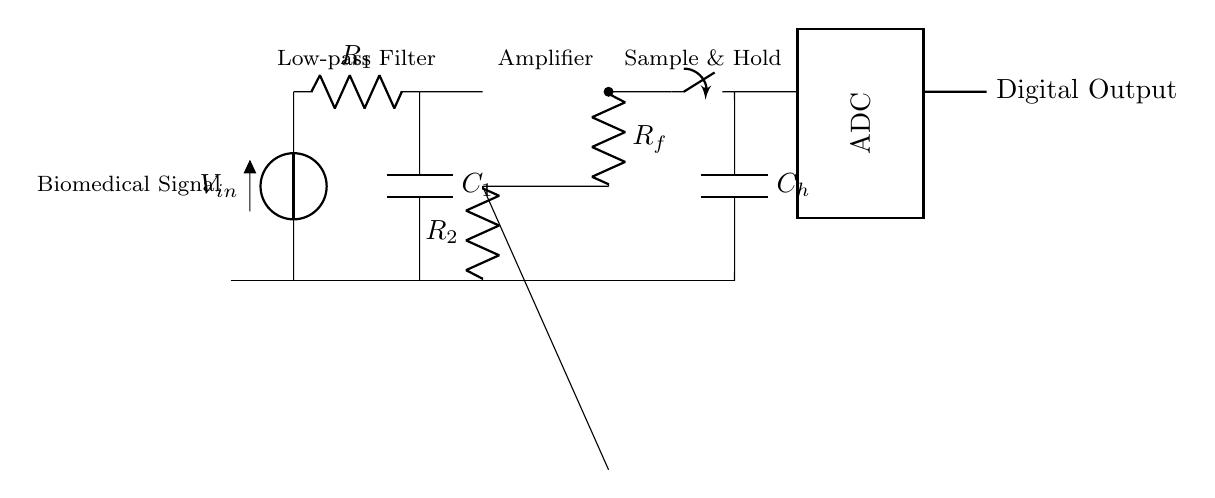What is the primary function of the component labeled as "V_in"? The component labeled as "V_in" represents the input voltage from a biomedical signal, which is the signal that the circuit is designed to process.
Answer: input voltage What type of filter is represented in the circuit? The low-pass filter is defined by the resistor R1 and capacitor C1, which filter out high-frequency noise from the input signal.
Answer: Low-pass filter What are the two components used in the amplifier section? The amplifier section uses a resistor (R2) and a feedback resistor (R_f), which are essential for controlling the gain of the operational amplifier in the circuit.
Answer: R2 and R_f What is the function of the component labeled as "C_h"? C_h is a capacitor used in the sample-and-hold stage, allowing the circuit to capture and hold the voltage value of the input signal for processing by the ADC.
Answer: capacitor How is the digital output represented in the circuit? The digital output is shown as a line labeled "Digital Output" that connects from the ADC, indicating the processed digital signal that results from the analog-to-digital conversion.
Answer: Digital Output What is the role of the switch connected to the sample-and-hold capacitor? The switch controls the connection to C_h, allowing it to charge when the signal is sampled and hold that value until the ADC processes it.
Answer: controls charging What type of output does this circuit ultimately provide? The circuit ultimately provides a digital output that represents the sampled and processed biomedical analog signal in a digital format suitable for further analysis.
Answer: digital output 